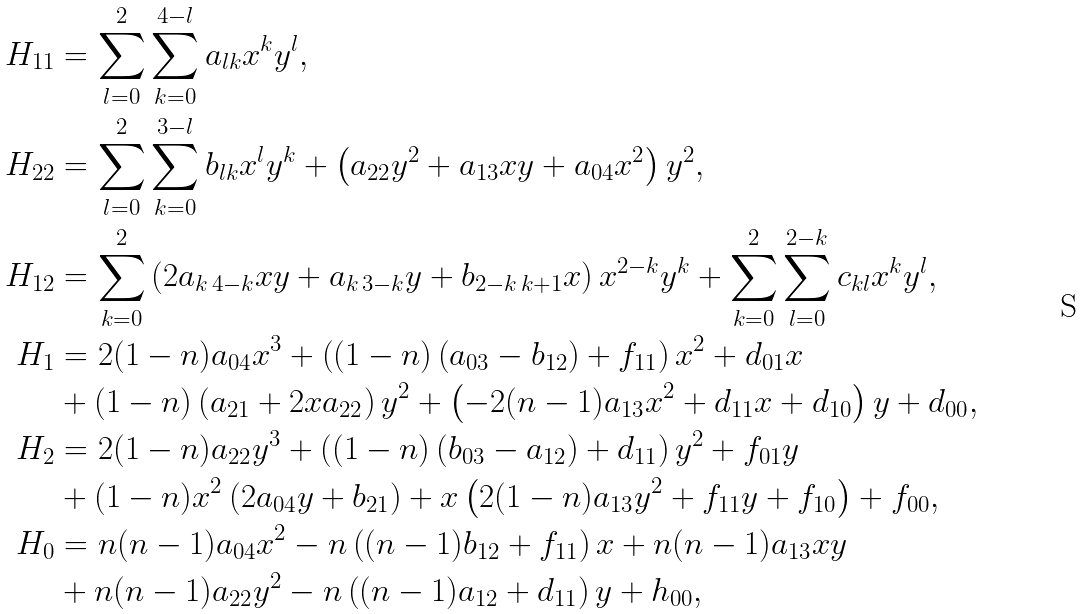<formula> <loc_0><loc_0><loc_500><loc_500>H _ { 1 1 } & = \sum _ { l = 0 } ^ { 2 } \sum _ { k = 0 } ^ { 4 - l } a _ { l k } x ^ { k } y ^ { l } , \\ H _ { 2 2 } & = \sum _ { l = 0 } ^ { 2 } \sum _ { k = 0 } ^ { 3 - l } b _ { l k } x ^ { l } y ^ { k } + \left ( a _ { 2 2 } y ^ { 2 } + a _ { 1 3 } x y + a _ { 0 4 } x ^ { 2 } \right ) y ^ { 2 } , \\ H _ { 1 2 } & = \sum _ { k = 0 } ^ { 2 } \left ( 2 a _ { k \, 4 - k } x y + a _ { k \, 3 - k } y + b _ { 2 - k \, k + 1 } x \right ) x ^ { 2 - k } y ^ { k } + \sum _ { k = 0 } ^ { 2 } \sum _ { l = 0 } ^ { 2 - k } c _ { k l } x ^ { k } y ^ { l } , \\ H _ { 1 } & = 2 ( 1 - n ) a _ { 0 4 } x ^ { 3 } + \left ( ( 1 - n ) \left ( a _ { 0 3 } - b _ { 1 2 } \right ) + f _ { 1 1 } \right ) x ^ { 2 } + d _ { 0 1 } x \\ & + ( 1 - n ) \left ( a _ { 2 1 } + 2 x a _ { 2 2 } \right ) y ^ { 2 } + \left ( - 2 ( n - 1 ) a _ { 1 3 } x ^ { 2 } + d _ { 1 1 } x + d _ { 1 0 } \right ) y + d _ { 0 0 } , \\ H _ { 2 } & = 2 ( 1 - n ) a _ { 2 2 } y ^ { 3 } + \left ( ( 1 - n ) \left ( b _ { 0 3 } - a _ { 1 2 } \right ) + d _ { 1 1 } \right ) y ^ { 2 } + f _ { 0 1 } y \\ & + ( 1 - n ) x ^ { 2 } \left ( 2 a _ { 0 4 } y + b _ { 2 1 } \right ) + x \left ( 2 ( 1 - n ) a _ { 1 3 } y ^ { 2 } + f _ { 1 1 } y + f _ { 1 0 } \right ) + f _ { 0 0 } , \\ H _ { 0 } & = n ( n - 1 ) a _ { 0 4 } x ^ { 2 } - n \left ( ( n - 1 ) b _ { 1 2 } + f _ { 1 1 } \right ) x + n ( n - 1 ) a _ { 1 3 } x y \\ & + n ( n - 1 ) a _ { 2 2 } y ^ { 2 } - n \left ( ( n - 1 ) a _ { 1 2 } + d _ { 1 1 } \right ) y + h _ { 0 0 } ,</formula> 